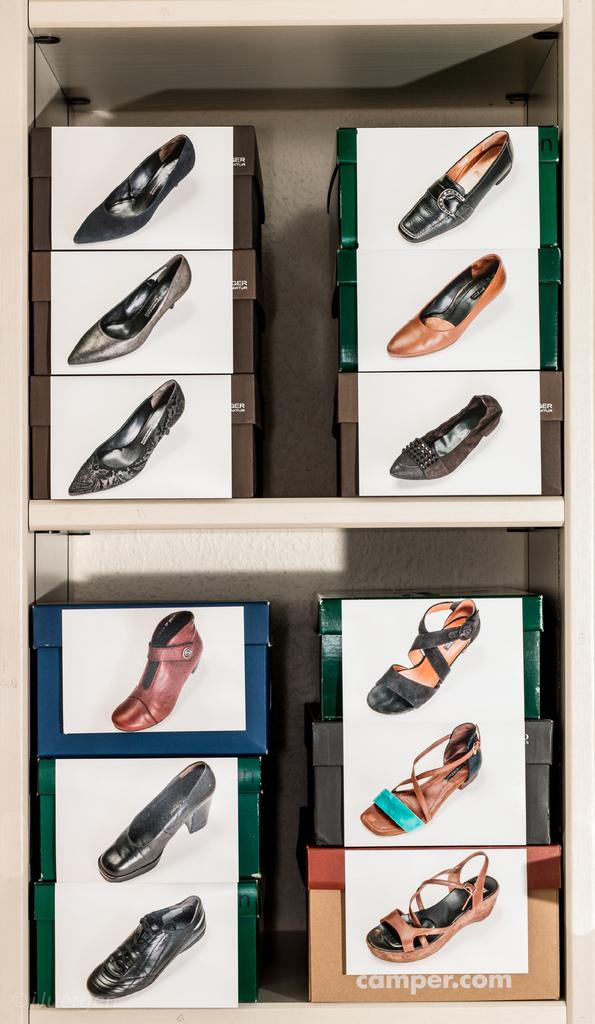What can be seen in the image? There are racks in the image, and they have shoe boxes on them. What is displayed above the racks? There are shoe pictures above the racks. Can you see your dad playing with a marble in the image? There is no dad, marble, or any play activity depicted in the image. 